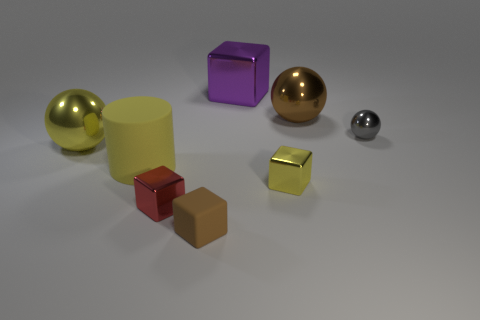Subtract all metallic blocks. How many blocks are left? 1 Subtract 1 spheres. How many spheres are left? 2 Add 1 tiny matte objects. How many objects exist? 9 Subtract all gray spheres. How many spheres are left? 2 Subtract all cylinders. How many objects are left? 7 Subtract 0 cyan blocks. How many objects are left? 8 Subtract all red cylinders. Subtract all cyan balls. How many cylinders are left? 1 Subtract all balls. Subtract all big gray spheres. How many objects are left? 5 Add 3 big purple shiny things. How many big purple shiny things are left? 4 Add 5 large cyan metallic cylinders. How many large cyan metallic cylinders exist? 5 